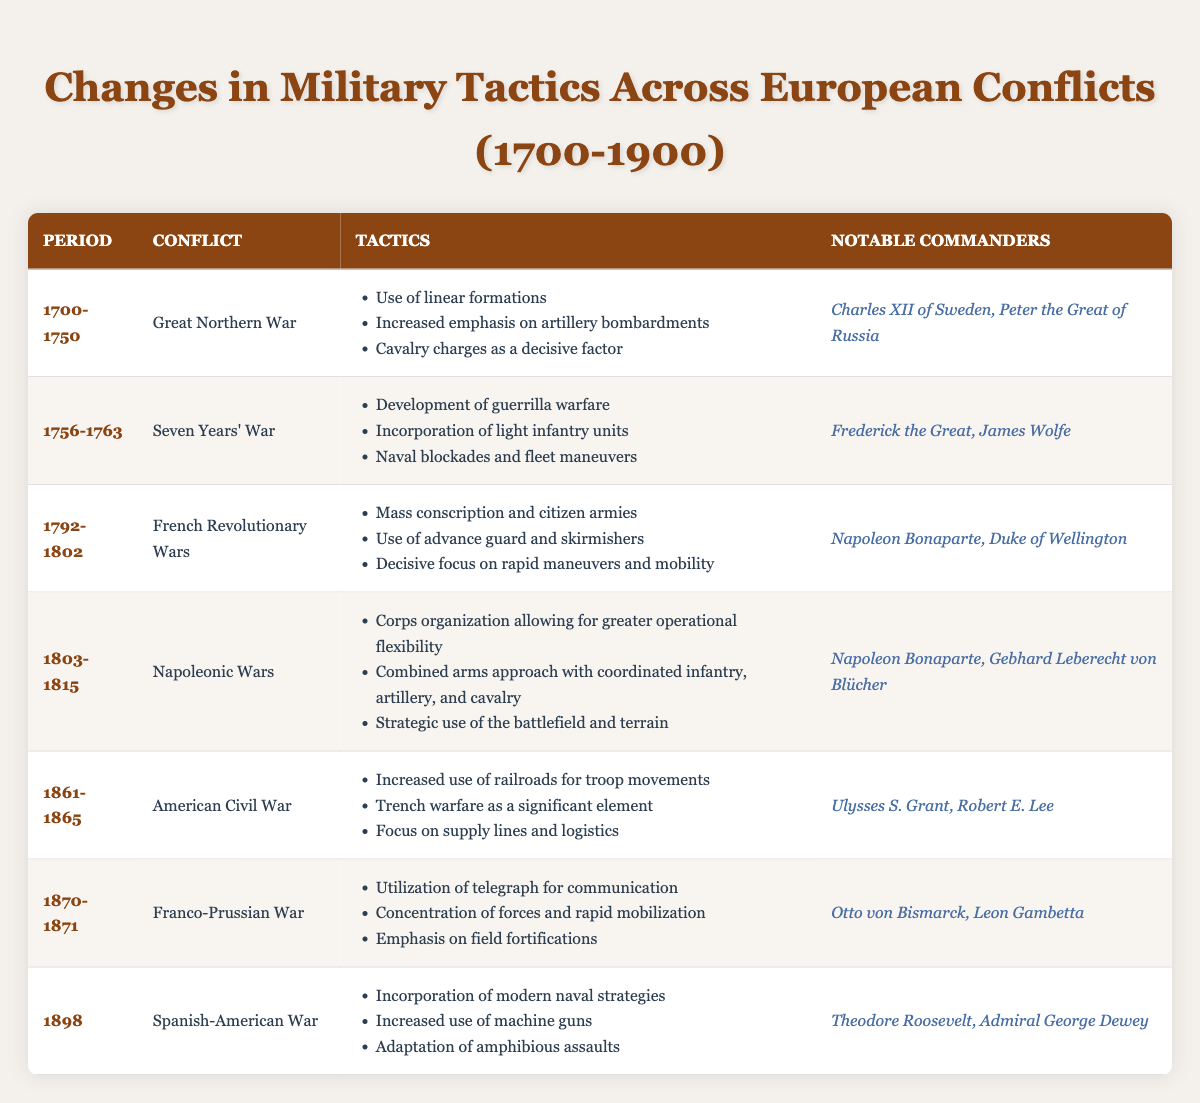What tactics were emphasized during the Great Northern War? According to the table, the tactics emphasized during the Great Northern War included the use of linear formations, increased emphasis on artillery bombardments, and cavalry charges as a decisive factor. These tactics can be found in the row corresponding to the Great Northern War, specifically listed under "Tactics".
Answer: Use of linear formations, increased emphasis on artillery bombardments, cavalry charges as a decisive factor Which notable commanders led the forces during the Napoleonic Wars? From the table, the notable commanders of the Napoleonic Wars were Napoleon Bonaparte and Gebhard Leberecht von Blücher, as listed in the corresponding row for that conflict.
Answer: Napoleon Bonaparte, Gebhard Leberecht von Blücher Was trench warfare a significant element in the tactics of the Seven Years' War? The table does not list trench warfare as a tactic used during the Seven Years' War. Instead, it highlights the development of guerrilla warfare, incorporation of light infantry units, and naval blockades. Therefore, trench warfare was not a significant element for this conflict.
Answer: No Between which years did the American Civil War occur? The table indicates that the American Civil War took place from 1861 to 1865, as seen in the row dedicated to that conflict. This provides the exact years of the war.
Answer: 1861-1865 What was a common tactic noted in conflicts between 1700 and 1900 that focused on rapid mobilization? The Franco-Prussian War included tactics emphasizing rapid mobilization, as stated in its row where it mentions "Concentration of forces and rapid mobilization." This indicates a common focus on quick troop movements during that conflict.
Answer: Rapid mobilization was notable in the Franco-Prussian War How many notable commanders are mentioned for the Spanish-American War, and who are they? The row for the Spanish-American War lists two notable commanders: Theodore Roosevelt and Admiral George Dewey. Thus, there are two notable commanders mentioned for this conflict.
Answer: Two: Theodore Roosevelt, Admiral George Dewey Which conflict introduced modern naval strategies according to the table? The Spanish-American War, as identified in the table, is noted for its incorporation of modern naval strategies. This can be found under the "Tactics" section of the Spanish-American War row.
Answer: Spanish-American War Did the tactics of the French Revolutionary Wars include the use of advance guard and skirmishers? Yes, the tactics listed for the French Revolutionary Wars include the use of advance guard and skirmishers, which can be directly referenced from the table under that conflict's tactics section.
Answer: Yes 